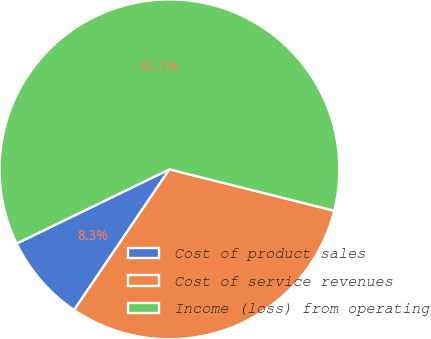Convert chart. <chart><loc_0><loc_0><loc_500><loc_500><pie_chart><fcel>Cost of product sales<fcel>Cost of service revenues<fcel>Income (loss) from operating<nl><fcel>8.33%<fcel>30.56%<fcel>61.11%<nl></chart> 